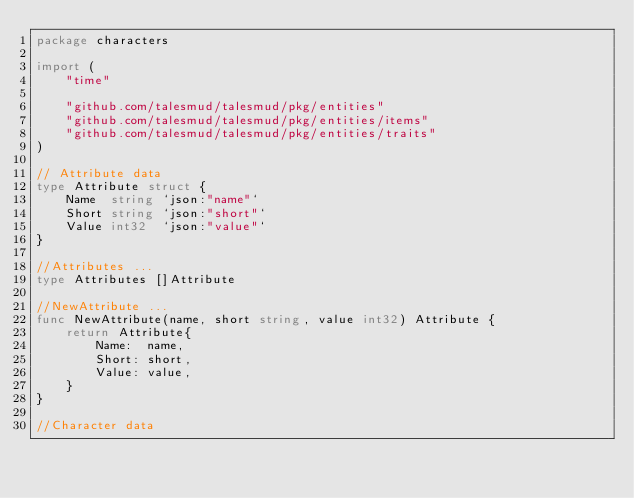<code> <loc_0><loc_0><loc_500><loc_500><_Go_>package characters

import (
	"time"

	"github.com/talesmud/talesmud/pkg/entities"
	"github.com/talesmud/talesmud/pkg/entities/items"
	"github.com/talesmud/talesmud/pkg/entities/traits"
)

// Attribute data
type Attribute struct {
	Name  string `json:"name"`
	Short string `json:"short"`
	Value int32  `json:"value"`
}

//Attributes ...
type Attributes []Attribute

//NewAttribute ...
func NewAttribute(name, short string, value int32) Attribute {
	return Attribute{
		Name:  name,
		Short: short,
		Value: value,
	}
}

//Character data</code> 